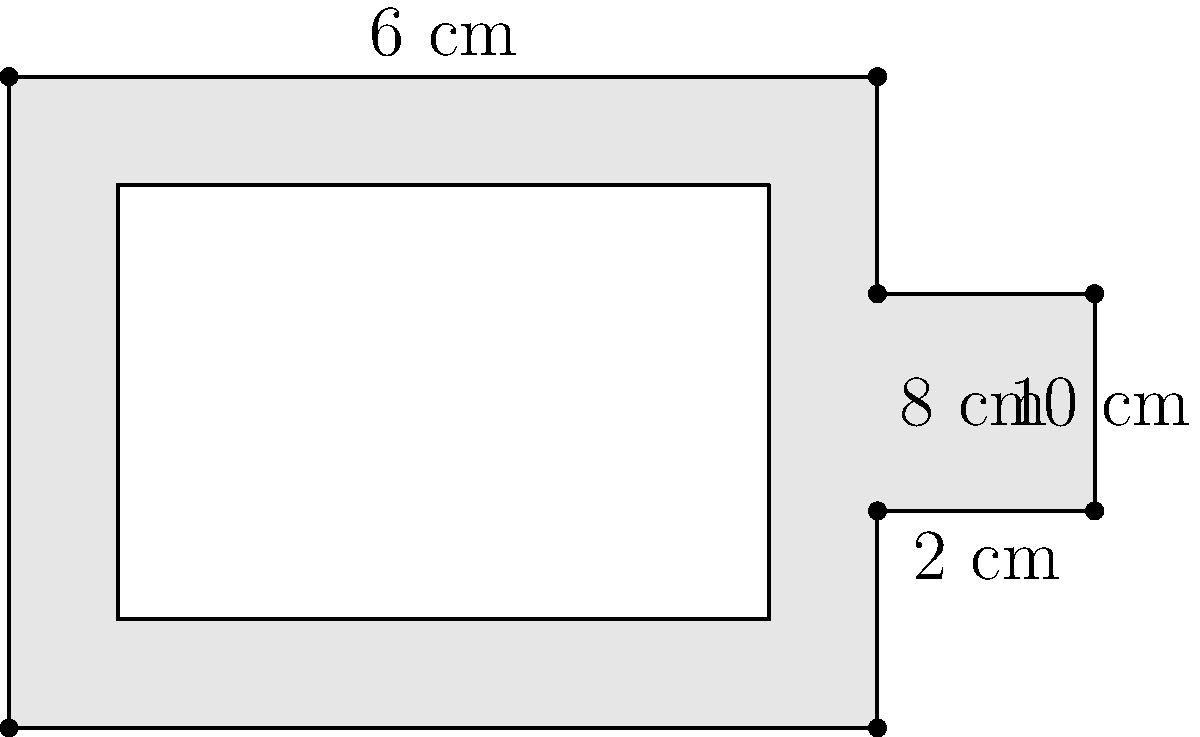Jenn Vix is known for her innovative use of synthesizers in her music. Imagine she has a custom-made synthesizer with a unique shape, as shown in the diagram. Calculate the surface area of the top face of this synthesizer. Assume the synthesizer is perfectly flat and ignore the area of the keys. To calculate the surface area of the top face of the synthesizer, we need to break it down into simpler shapes and add their areas together. Let's approach this step-by-step:

1. The main body of the synthesizer is a rectangle:
   Length = 8 cm, Width = 6 cm
   Area of main body = $8 \times 6 = 48$ cm²

2. There's an additional rectangular protrusion on the right side:
   Length = 2 cm, Width = 2 cm
   Area of protrusion = $2 \times 2 = 4$ cm²

3. The total surface area is the sum of these two areas:
   Total surface area = Area of main body + Area of protrusion
   Total surface area = $48 + 4 = 52$ cm²

Therefore, the surface area of the top face of Jenn Vix's custom synthesizer is 52 square centimeters.
Answer: 52 cm² 